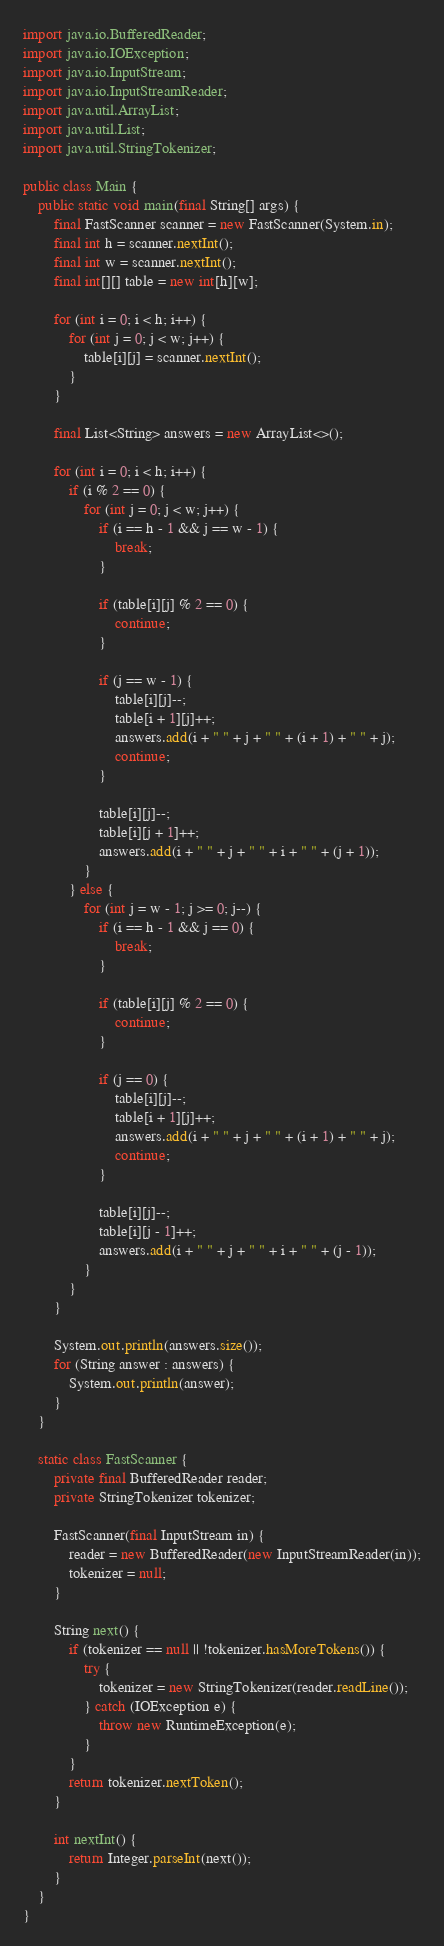Convert code to text. <code><loc_0><loc_0><loc_500><loc_500><_Java_>
import java.io.BufferedReader;
import java.io.IOException;
import java.io.InputStream;
import java.io.InputStreamReader;
import java.util.ArrayList;
import java.util.List;
import java.util.StringTokenizer;

public class Main {
    public static void main(final String[] args) {
        final FastScanner scanner = new FastScanner(System.in);
        final int h = scanner.nextInt();
        final int w = scanner.nextInt();
        final int[][] table = new int[h][w];

        for (int i = 0; i < h; i++) {
            for (int j = 0; j < w; j++) {
                table[i][j] = scanner.nextInt();
            }
        }

        final List<String> answers = new ArrayList<>();

        for (int i = 0; i < h; i++) {
            if (i % 2 == 0) {
                for (int j = 0; j < w; j++) {
                    if (i == h - 1 && j == w - 1) {
                        break;
                    }

                    if (table[i][j] % 2 == 0) {
                        continue;
                    }

                    if (j == w - 1) {
                        table[i][j]--;
                        table[i + 1][j]++;
                        answers.add(i + " " + j + " " + (i + 1) + " " + j);
                        continue;
                    }

                    table[i][j]--;
                    table[i][j + 1]++;
                    answers.add(i + " " + j + " " + i + " " + (j + 1));
                }
            } else {
                for (int j = w - 1; j >= 0; j--) {
                    if (i == h - 1 && j == 0) {
                        break;
                    }

                    if (table[i][j] % 2 == 0) {
                        continue;
                    }

                    if (j == 0) {
                        table[i][j]--;
                        table[i + 1][j]++;
                        answers.add(i + " " + j + " " + (i + 1) + " " + j);
                        continue;
                    }

                    table[i][j]--;
                    table[i][j - 1]++;
                    answers.add(i + " " + j + " " + i + " " + (j - 1));
                }
            }
        }

        System.out.println(answers.size());
        for (String answer : answers) {
            System.out.println(answer);
        }
    }

    static class FastScanner {
        private final BufferedReader reader;
        private StringTokenizer tokenizer;

        FastScanner(final InputStream in) {
            reader = new BufferedReader(new InputStreamReader(in));
            tokenizer = null;
        }

        String next() {
            if (tokenizer == null || !tokenizer.hasMoreTokens()) {
                try {
                    tokenizer = new StringTokenizer(reader.readLine());
                } catch (IOException e) {
                    throw new RuntimeException(e);
                }
            }
            return tokenizer.nextToken();
        }

        int nextInt() {
            return Integer.parseInt(next());
        }
    }
}
</code> 